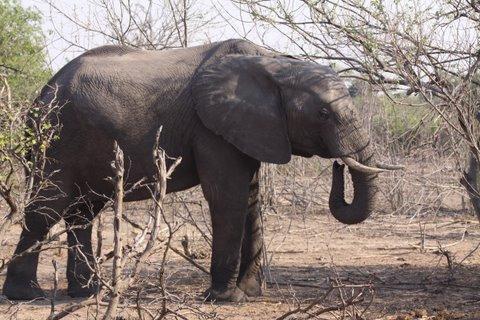How many people have pink hair?
Give a very brief answer. 0. 